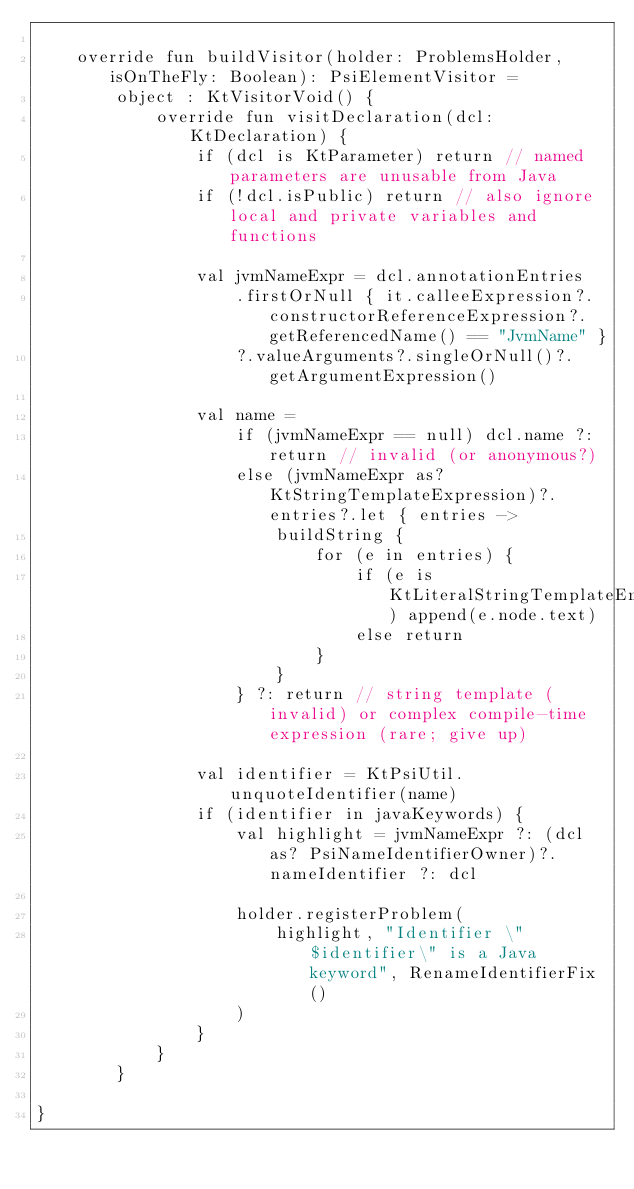Convert code to text. <code><loc_0><loc_0><loc_500><loc_500><_Kotlin_>
    override fun buildVisitor(holder: ProblemsHolder, isOnTheFly: Boolean): PsiElementVisitor =
        object : KtVisitorVoid() {
            override fun visitDeclaration(dcl: KtDeclaration) {
                if (dcl is KtParameter) return // named parameters are unusable from Java
                if (!dcl.isPublic) return // also ignore local and private variables and functions

                val jvmNameExpr = dcl.annotationEntries
                    .firstOrNull { it.calleeExpression?.constructorReferenceExpression?.getReferencedName() == "JvmName" }
                    ?.valueArguments?.singleOrNull()?.getArgumentExpression()

                val name =
                    if (jvmNameExpr == null) dcl.name ?: return // invalid (or anonymous?)
                    else (jvmNameExpr as? KtStringTemplateExpression)?.entries?.let { entries ->
                        buildString {
                            for (e in entries) {
                                if (e is KtLiteralStringTemplateEntry) append(e.node.text)
                                else return
                            }
                        }
                    } ?: return // string template (invalid) or complex compile-time expression (rare; give up)

                val identifier = KtPsiUtil.unquoteIdentifier(name)
                if (identifier in javaKeywords) {
                    val highlight = jvmNameExpr ?: (dcl as? PsiNameIdentifierOwner)?.nameIdentifier ?: dcl

                    holder.registerProblem(
                        highlight, "Identifier \"$identifier\" is a Java keyword", RenameIdentifierFix()
                    )
                }
            }
        }

}
</code> 